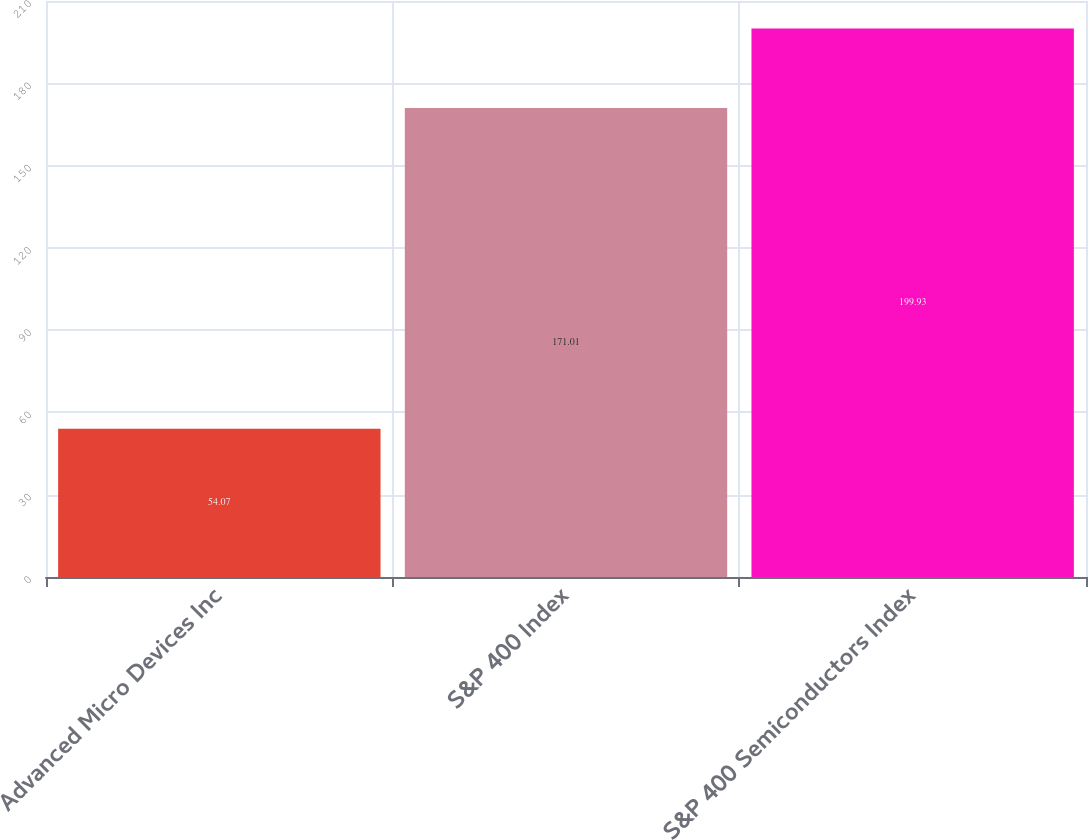Convert chart to OTSL. <chart><loc_0><loc_0><loc_500><loc_500><bar_chart><fcel>Advanced Micro Devices Inc<fcel>S&P 400 Index<fcel>S&P 400 Semiconductors Index<nl><fcel>54.07<fcel>171.01<fcel>199.93<nl></chart> 